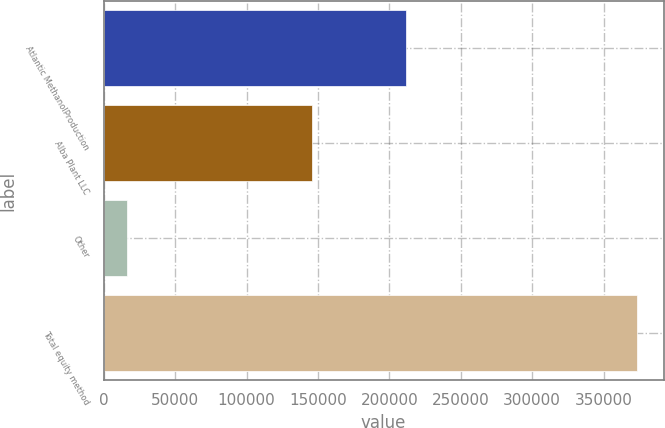<chart> <loc_0><loc_0><loc_500><loc_500><bar_chart><fcel>Atlantic MethanolProduction<fcel>Alba Plant LLC<fcel>Other<fcel>Total equity method<nl><fcel>211325<fcel>146051<fcel>15996<fcel>373372<nl></chart> 